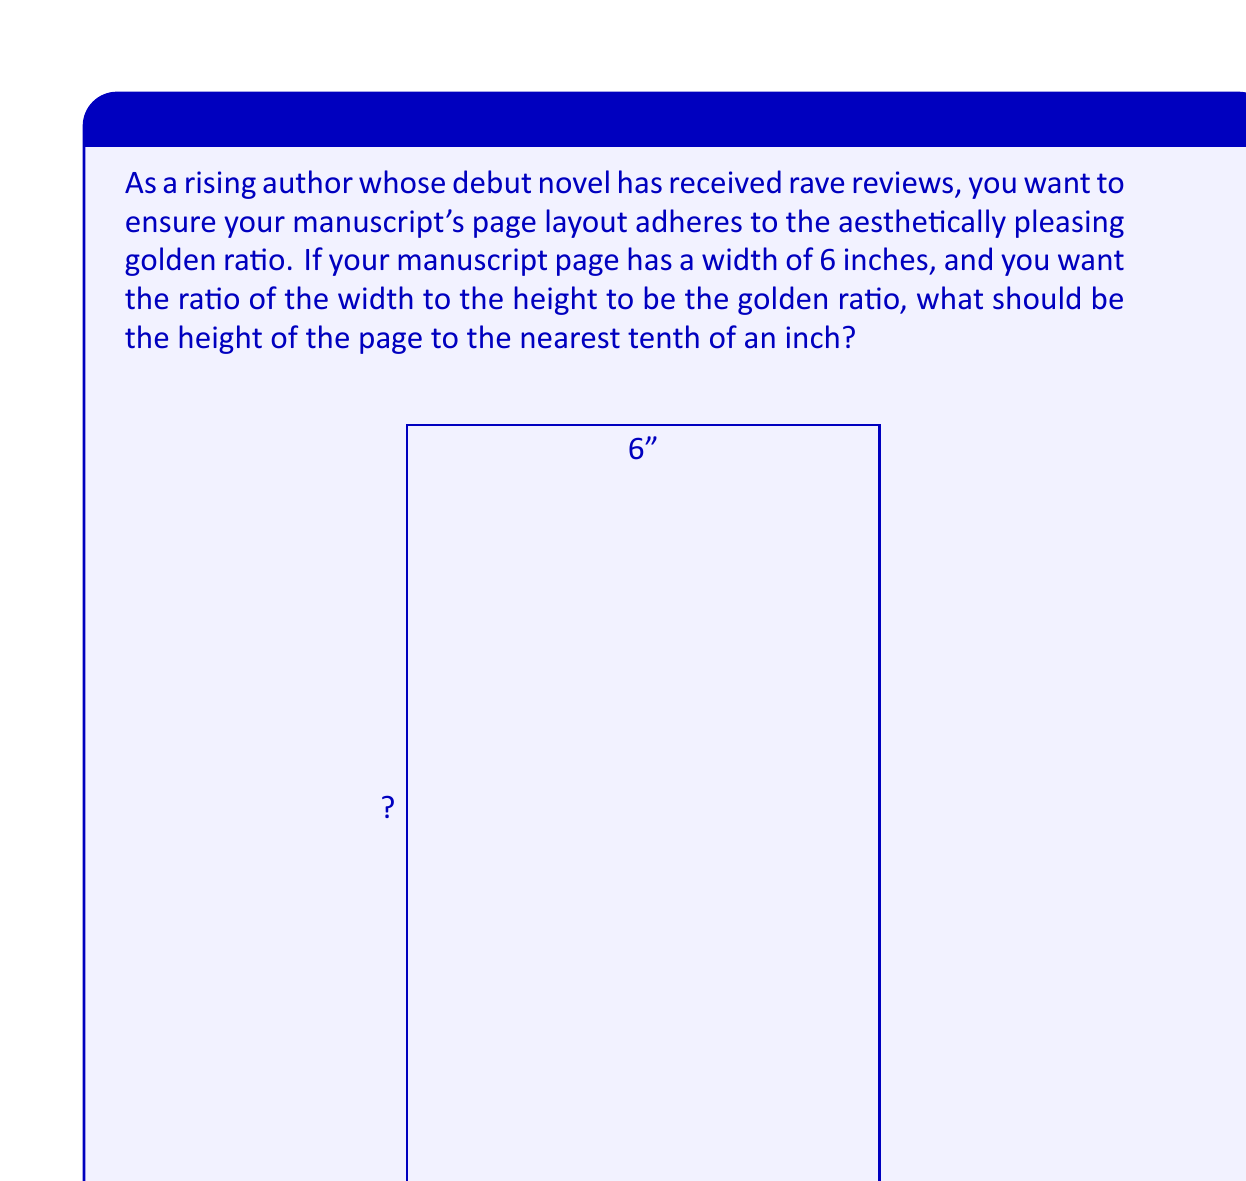Can you answer this question? To solve this problem, we need to use the properties of the golden ratio and apply them to the dimensions of the manuscript page.

1) The golden ratio, often denoted by the Greek letter φ (phi), is approximately equal to 1.618033988749895.

2) In our case, we want the ratio of width to height to be equal to the golden ratio. Let's call the height h. We can express this as an equation:

   $$\frac{\text{width}}{\text{height}} = \phi$$

3) Substituting the known values:

   $$\frac{6}{h} = 1.618033988749895$$

4) To solve for h, we cross-multiply:

   $$6 = 1.618033988749895h$$

5) Now, we divide both sides by 1.618033988749895:

   $$h = \frac{6}{1.618033988749895}$$

6) Using a calculator or computer, we can evaluate this:

   $$h ≈ 3.708203932499369$$

7) Rounding to the nearest tenth of an inch as requested:

   $$h ≈ 3.7 \text{ inches}$$

Therefore, to achieve the golden ratio proportions, the height of the manuscript page should be approximately 3.7 inches.
Answer: 3.7 inches 